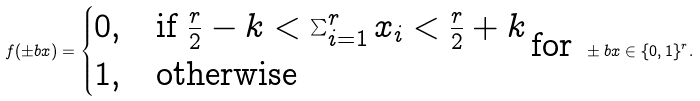Convert formula to latex. <formula><loc_0><loc_0><loc_500><loc_500>f ( \pm b { x } ) = \begin{cases} 0 , & \text {if } \frac { r } { 2 } - k < \sum _ { i = 1 } ^ { r } x _ { i } < \frac { r } { 2 } + k \\ 1 , & \text {otherwise} \end{cases} \text {for } \pm b { x } \in \{ 0 , 1 \} ^ { r } .</formula> 